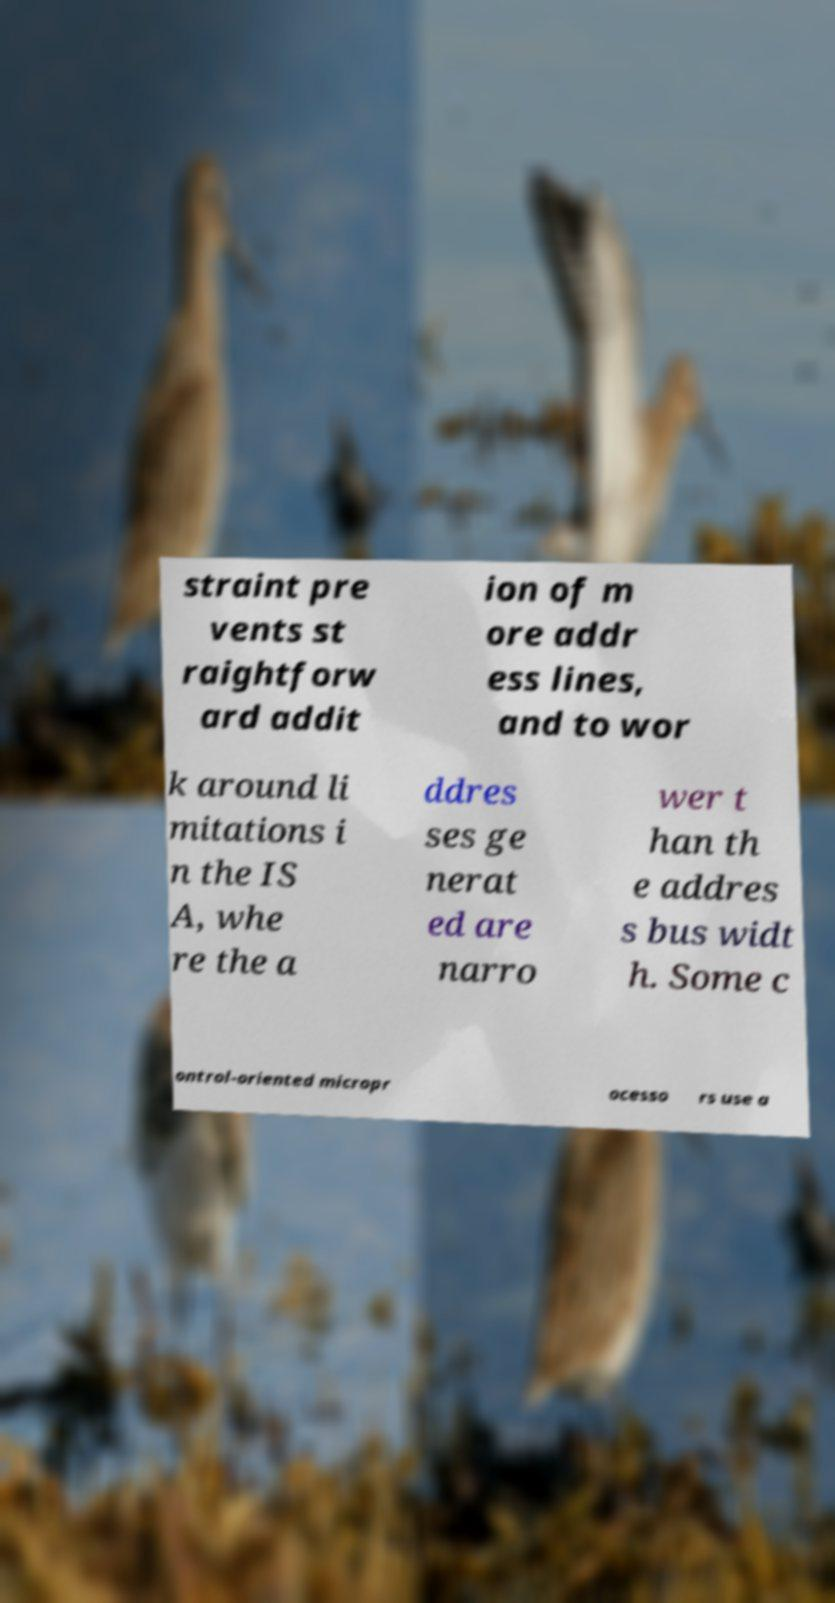For documentation purposes, I need the text within this image transcribed. Could you provide that? straint pre vents st raightforw ard addit ion of m ore addr ess lines, and to wor k around li mitations i n the IS A, whe re the a ddres ses ge nerat ed are narro wer t han th e addres s bus widt h. Some c ontrol-oriented micropr ocesso rs use a 